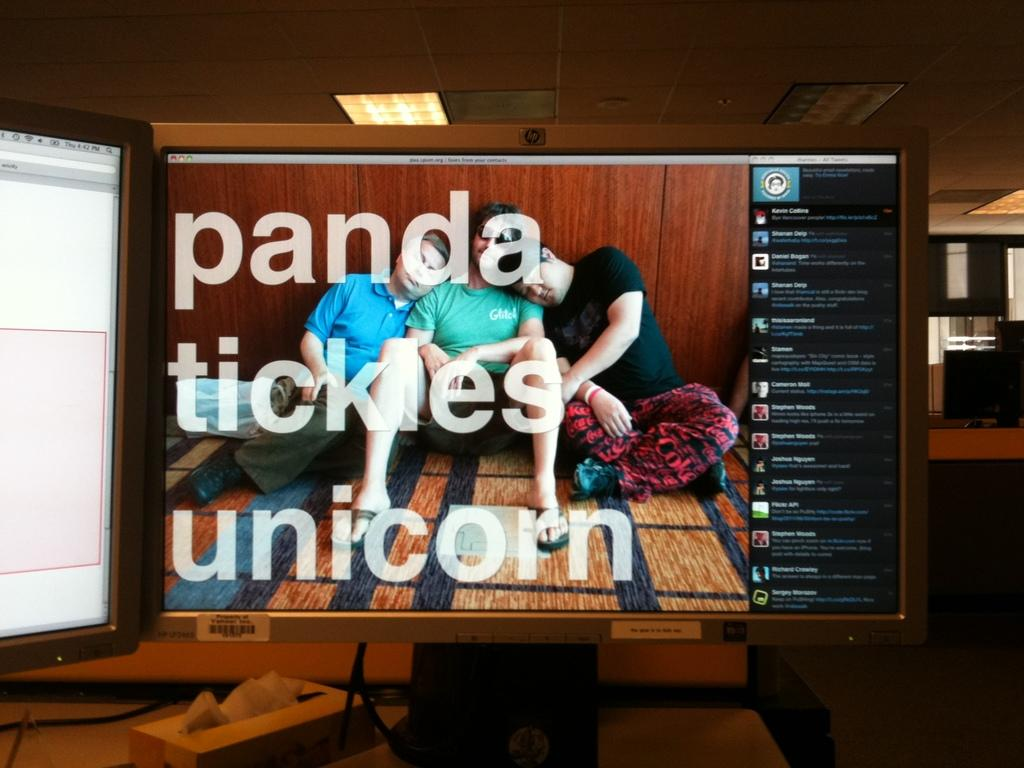<image>
Offer a succinct explanation of the picture presented. Multiple computer monitors where one has the phrase "panda tickles unicorn" on the screen. 